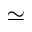<formula> <loc_0><loc_0><loc_500><loc_500>\simeq</formula> 